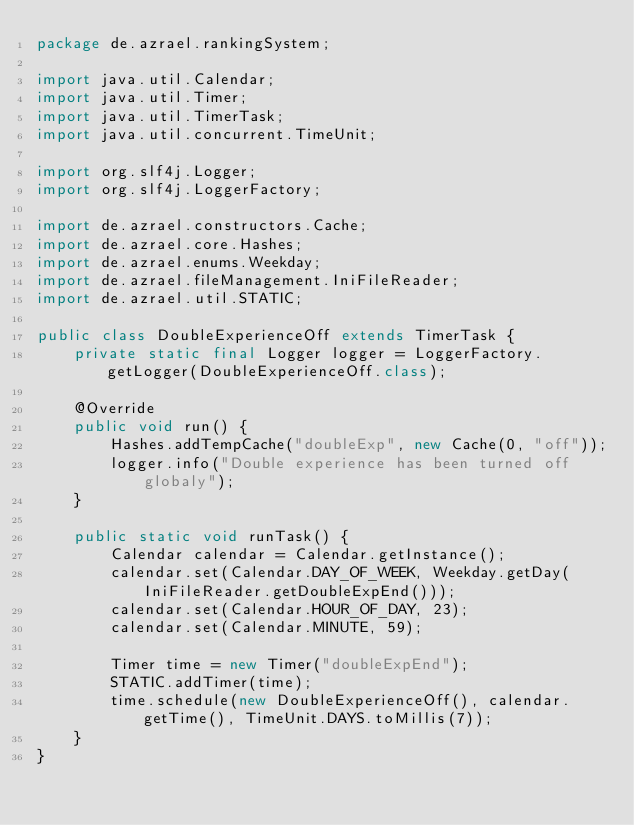<code> <loc_0><loc_0><loc_500><loc_500><_Java_>package de.azrael.rankingSystem;

import java.util.Calendar;
import java.util.Timer;
import java.util.TimerTask;
import java.util.concurrent.TimeUnit;

import org.slf4j.Logger;
import org.slf4j.LoggerFactory;

import de.azrael.constructors.Cache;
import de.azrael.core.Hashes;
import de.azrael.enums.Weekday;
import de.azrael.fileManagement.IniFileReader;
import de.azrael.util.STATIC;

public class DoubleExperienceOff extends TimerTask {
	private static final Logger logger = LoggerFactory.getLogger(DoubleExperienceOff.class);

	@Override
	public void run() {
		Hashes.addTempCache("doubleExp", new Cache(0, "off"));
		logger.info("Double experience has been turned off globaly");
	}
	
	public static void runTask() {
		Calendar calendar = Calendar.getInstance();
		calendar.set(Calendar.DAY_OF_WEEK, Weekday.getDay(IniFileReader.getDoubleExpEnd()));
		calendar.set(Calendar.HOUR_OF_DAY, 23);
		calendar.set(Calendar.MINUTE, 59);
		
		Timer time = new Timer("doubleExpEnd");
		STATIC.addTimer(time);
		time.schedule(new DoubleExperienceOff(), calendar.getTime(), TimeUnit.DAYS.toMillis(7));
	}
}
</code> 